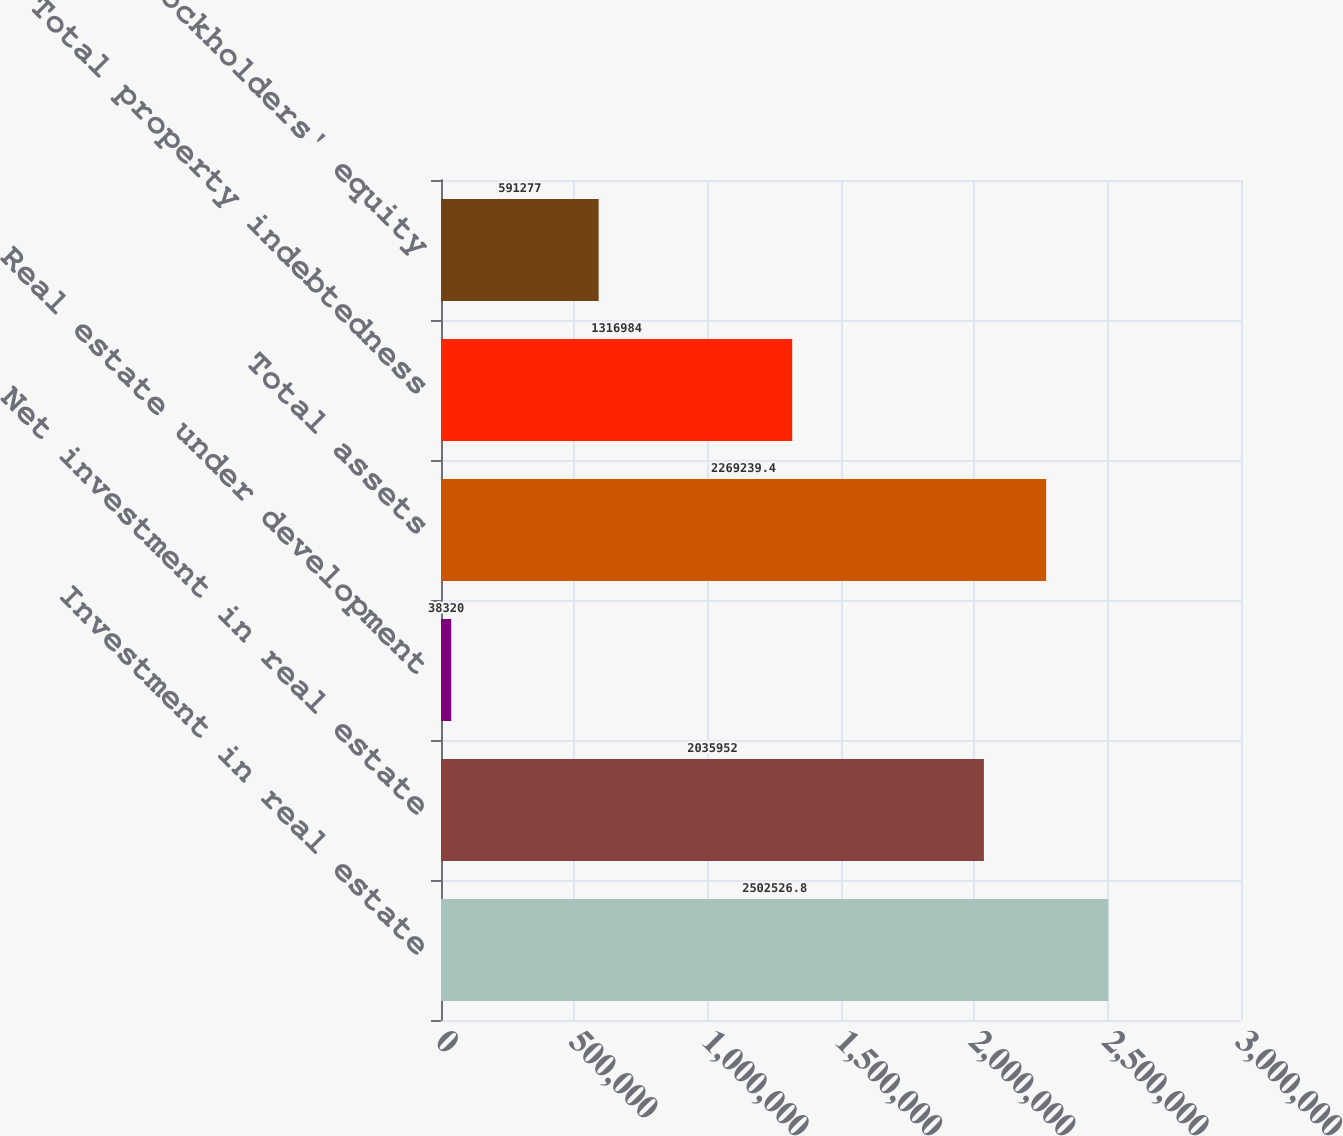Convert chart. <chart><loc_0><loc_0><loc_500><loc_500><bar_chart><fcel>Investment in real estate<fcel>Net investment in real estate<fcel>Real estate under development<fcel>Total assets<fcel>Total property indebtedness<fcel>Stockholders' equity<nl><fcel>2.50253e+06<fcel>2.03595e+06<fcel>38320<fcel>2.26924e+06<fcel>1.31698e+06<fcel>591277<nl></chart> 